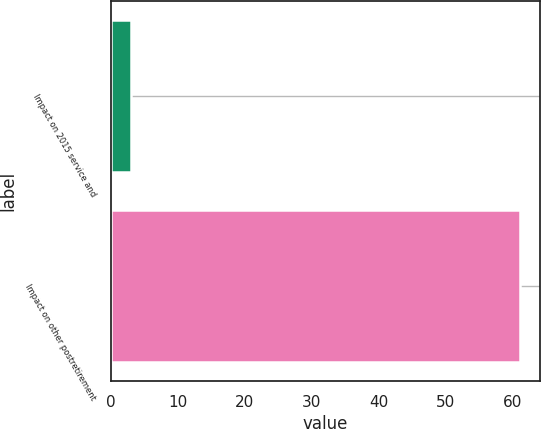Convert chart. <chart><loc_0><loc_0><loc_500><loc_500><bar_chart><fcel>Impact on 2015 service and<fcel>Impact on other postretirement<nl><fcel>3<fcel>61<nl></chart> 